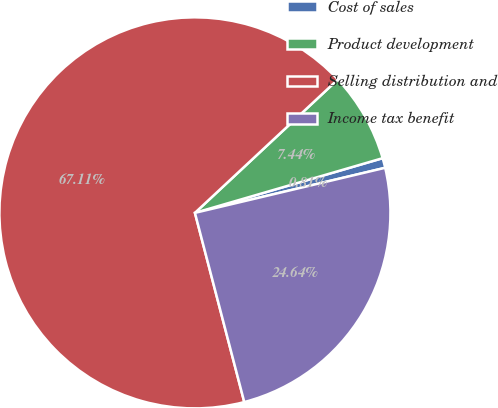Convert chart. <chart><loc_0><loc_0><loc_500><loc_500><pie_chart><fcel>Cost of sales<fcel>Product development<fcel>Selling distribution and<fcel>Income tax benefit<nl><fcel>0.81%<fcel>7.44%<fcel>67.11%<fcel>24.64%<nl></chart> 